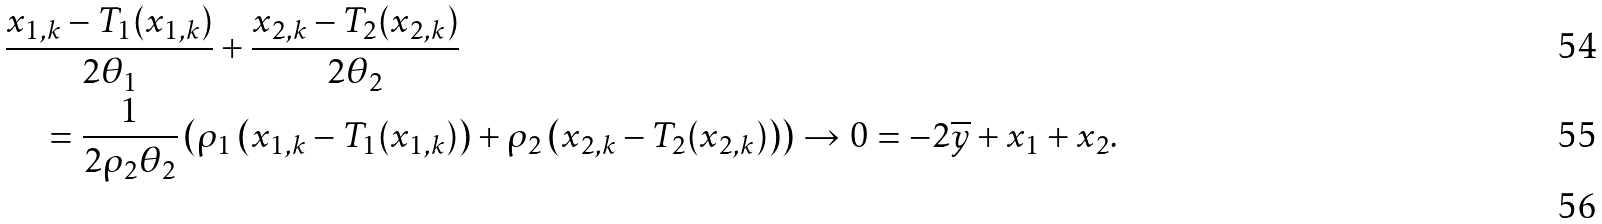<formula> <loc_0><loc_0><loc_500><loc_500>& \frac { x _ { 1 , k } - T _ { 1 } ( x _ { 1 , k } ) } { 2 \theta _ { 1 } } + \frac { x _ { 2 , k } - T _ { 2 } ( x _ { 2 , k } ) } { 2 \theta _ { 2 } } \\ & \quad = \frac { 1 } { 2 \rho _ { 2 } \theta _ { 2 } } \left ( \rho _ { 1 } \left ( x _ { 1 , k } - T _ { 1 } ( x _ { 1 , k } ) \right ) + \rho _ { 2 } \left ( x _ { 2 , k } - T _ { 2 } ( x _ { 2 , k } ) \right ) \right ) \to 0 = - 2 \overline { y } + x _ { 1 } + x _ { 2 } . \\</formula> 